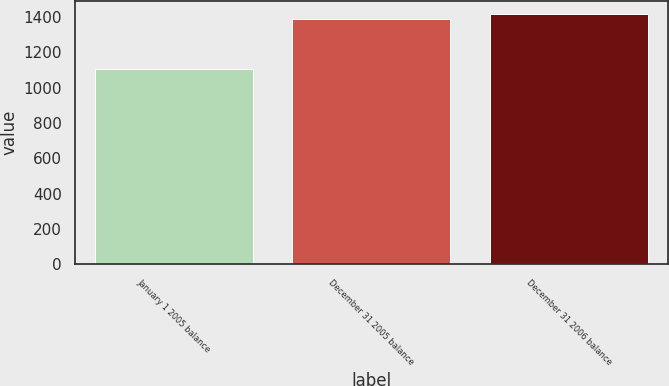<chart> <loc_0><loc_0><loc_500><loc_500><bar_chart><fcel>January 1 2005 balance<fcel>December 31 2005 balance<fcel>December 31 2006 balance<nl><fcel>1107.6<fcel>1390.7<fcel>1419.14<nl></chart> 